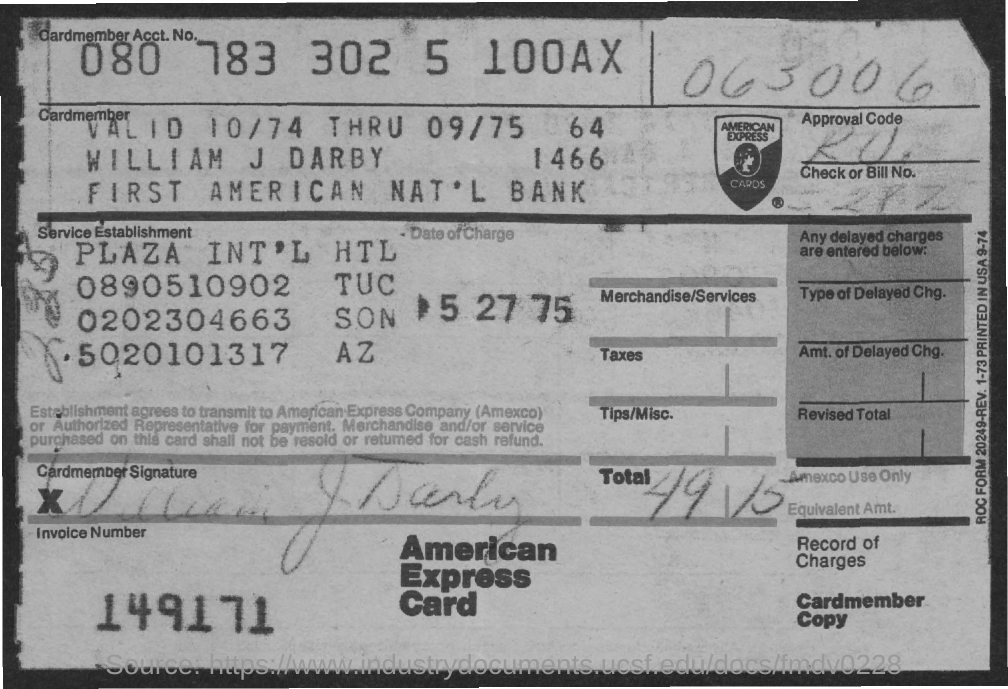Outline some significant characteristics in this image. The card holder's name is William J Darby. The invoice number is 149171. On what date did the change occur? May 27, 1975. The American Express Card is known as 'what is card name?' 